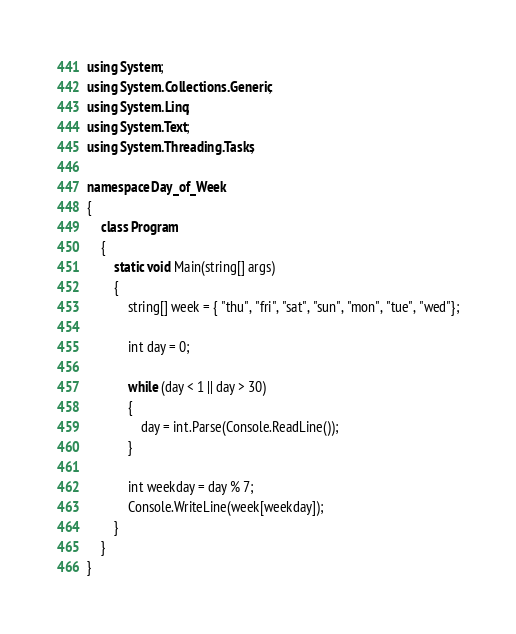Convert code to text. <code><loc_0><loc_0><loc_500><loc_500><_C#_>using System;
using System.Collections.Generic;
using System.Linq;
using System.Text;
using System.Threading.Tasks;

namespace Day_of_Week
{
    class Program
    {
        static void Main(string[] args)
        {
            string[] week = { "thu", "fri", "sat", "sun", "mon", "tue", "wed"};

            int day = 0;

            while (day < 1 || day > 30)
            {
                day = int.Parse(Console.ReadLine());
            }

            int weekday = day % 7;
            Console.WriteLine(week[weekday]);
        }
    }
}

</code> 